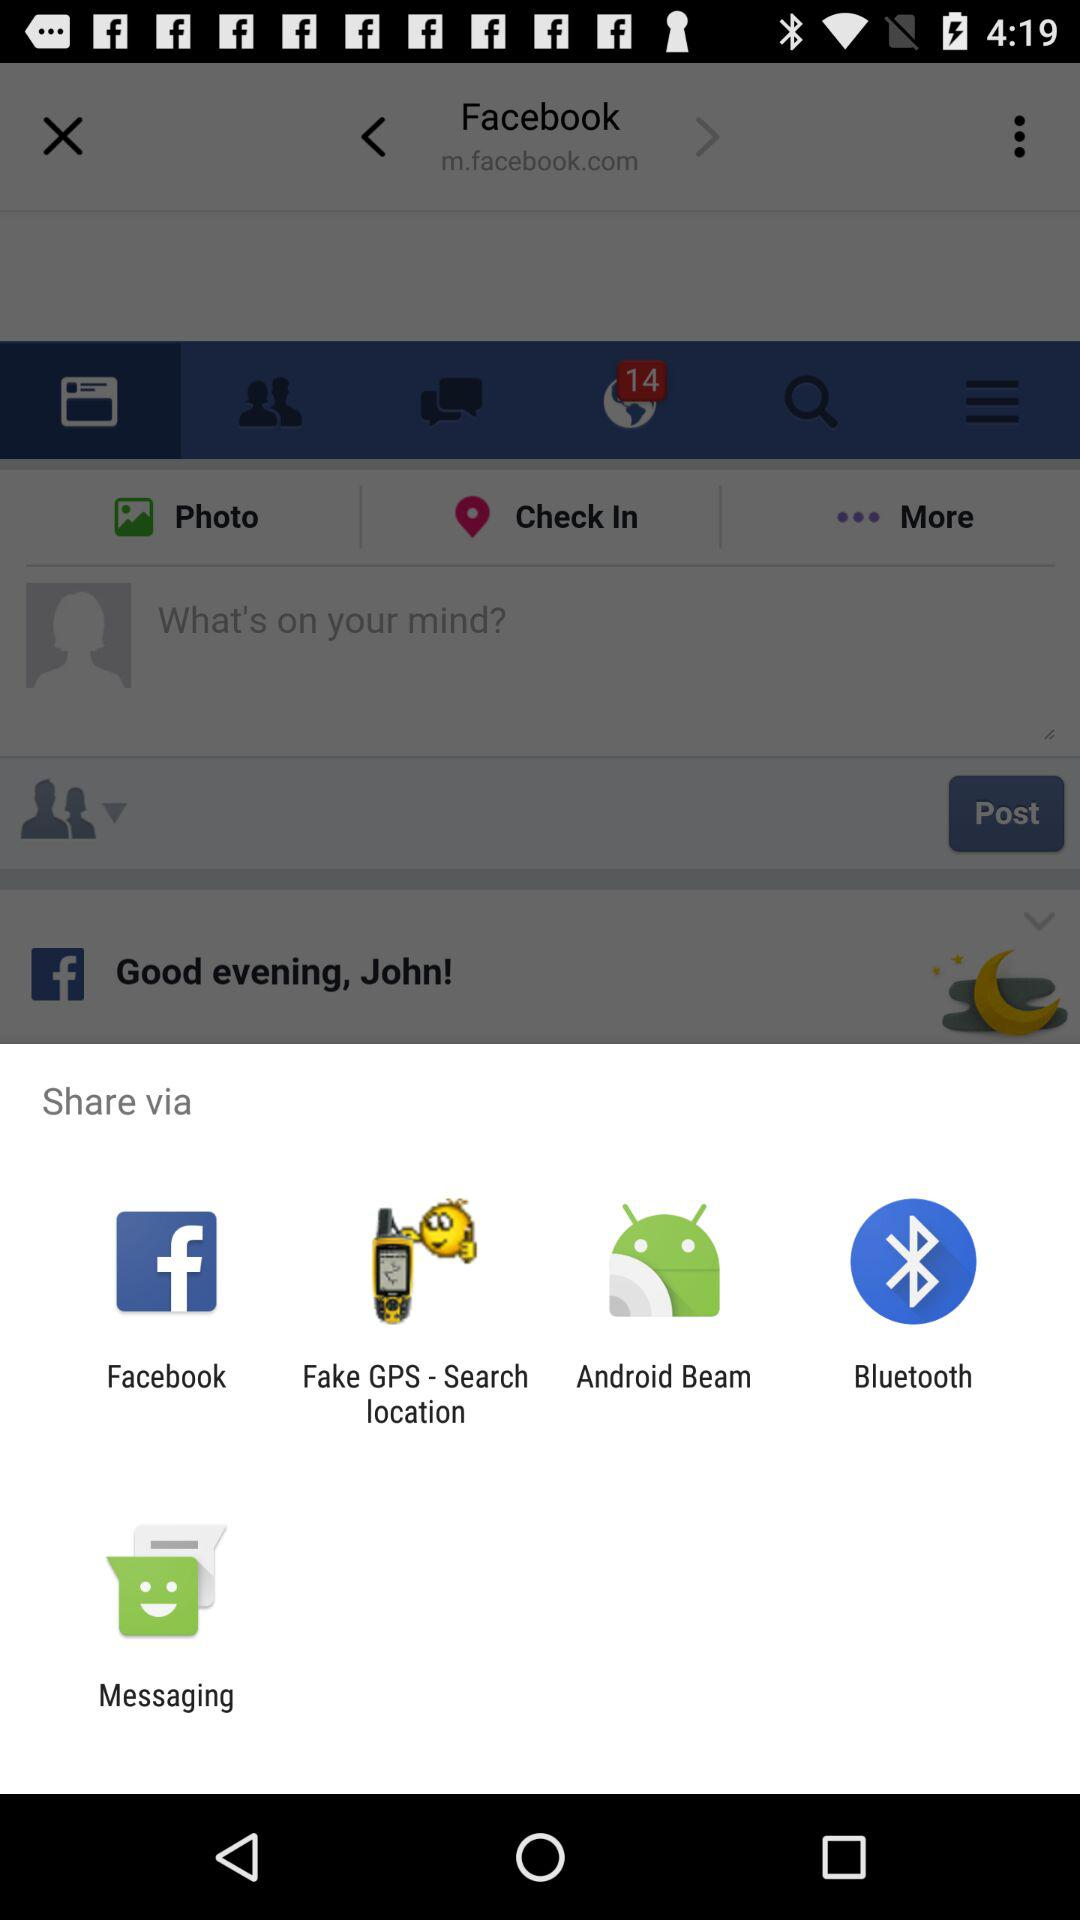What is the number of unseen notifications? The number of unseen notifications is 14. 